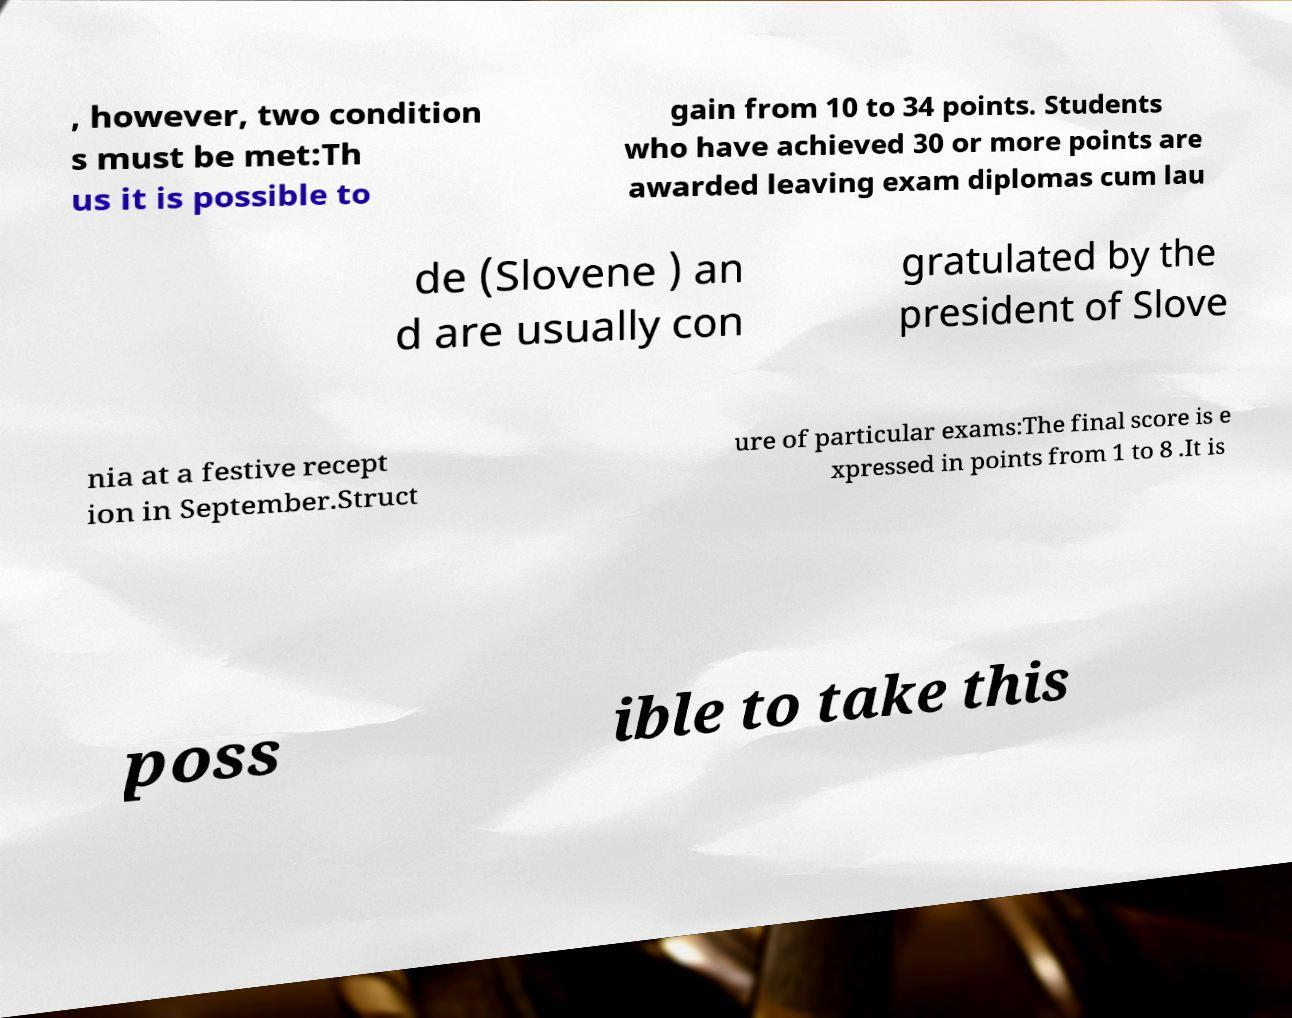I need the written content from this picture converted into text. Can you do that? , however, two condition s must be met:Th us it is possible to gain from 10 to 34 points. Students who have achieved 30 or more points are awarded leaving exam diplomas cum lau de (Slovene ) an d are usually con gratulated by the president of Slove nia at a festive recept ion in September.Struct ure of particular exams:The final score is e xpressed in points from 1 to 8 .It is poss ible to take this 